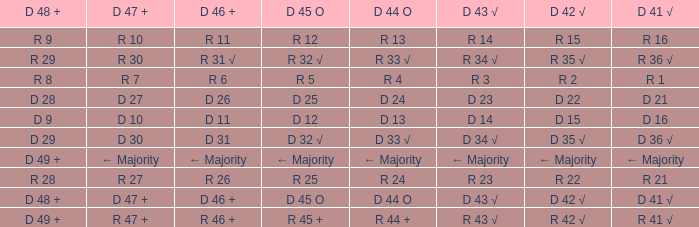What is the value of D 42 √, when the value of D 45 O is d 32 √? D 35 √. 